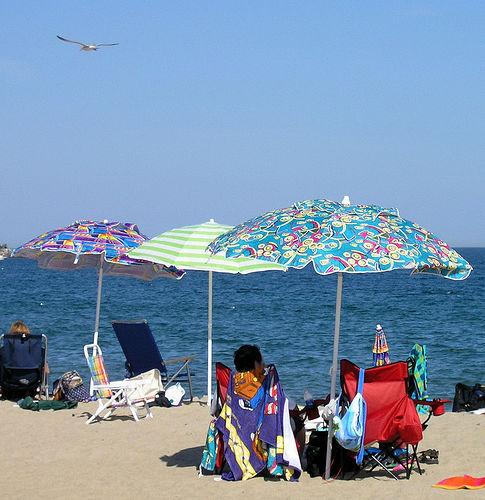Highlight the primary focus in the picture and explain its purpose or action. The main focus in the picture is the colorful beach umbrellas and people relaxing under them, suggesting a leisurely day at the beach. Mention the primary object in the picture and describe its action. The primary objects in the picture are the beach umbrellas, providing shade to the people sitting underneath, who are enjoying a day at the beach. State the chief subject in the photograph and describe its relevance. The chief subjects in the photograph are the beach umbrellas and the people under them, highlighting a common beach scene of relaxation and protection from the sun. Summarize the central aspect of the image and clarify its significance. The central aspect of this image is the beach setting with umbrellas and people, signifying leisure and the enjoyment of a sunny beach day. Identify the focal point in the image and explain the scene featuring it. The focal point is the colorful beach umbrellas and the people under them, portraying a typical scene of relaxation and leisure at the beach. Outline the most significant element in the image and elaborate on the situation surrounding it. The most significant elements are the beach umbrellas and the people under them, depicting a relaxing beach day where people seek shade and comfort. Detail the primary object and action portrayed within the image. The primary objects are the colorful beach umbrellas, which are used to provide shade for the people sitting underneath, enjoying the beach environment. Identify the principal focus in the image and elaborate on its behavior. The principal focus in the image is the beach scene with umbrellas and people, emphasizing leisure activities and relaxation on a sunny day. Comment on the most eye-catching element in the photo and expound on its function. The most eye-catching elements are the colorful beach umbrellas, serving the function of providing shade and adding visual appeal to the beach setting. Describe the prominent subject in the image and its corresponding activity. The prominent subjects are the beach umbrellas and the people under them, engaged in activities typical of a beach visit, like sitting, relaxing, and enjoying the seaside. 